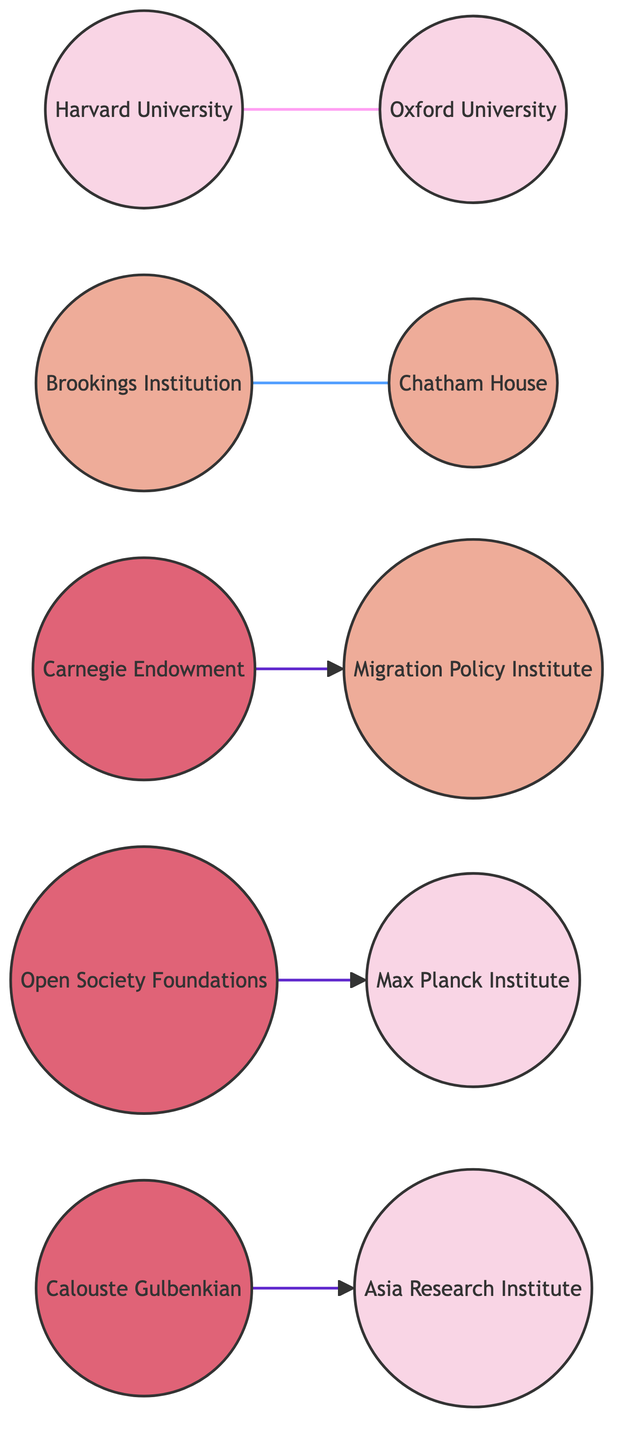What are the total number of nodes in the diagram? The diagram contains 10 nodes, which include various academic institutions, think tanks, and foundations listed in the data.
Answer: 10 What type of institution is Chatham House? Chatham House is identified as a "Think Tank" in the data provided, indicating its role in research and policy analysis.
Answer: Think Tank Which two nodes have a "Collaborative Research" relationship? The relationship of "Collaborative Research" exists between Harvard University and Oxford University, as reflected in the links data.
Answer: Harvard University and Oxford University What is the location of the Max Planck Institute for the Study of Religious and Ethnic Diversity? The data specifies that the Max Planck Institute for the Study of Religious and Ethnic Diversity is located in Göttingen, Germany.
Answer: Göttingen, Germany How many links are there between the nodes? The data lists 5 connections (links) between the institutions, showing various types of relationships among them.
Answer: 5 Which foundation is linked to the Migration Policy Institute? The Carnegie Endowment for International Peace has a link to the Migration Policy Institute, characterized as a "Funding" relationship.
Answer: Carnegie Endowment for International Peace What type of relationship connects Calouste Gulbenkian Foundation with Asia Research Institute? The type of relationship between Calouste Gulbenkian Foundation and Asia Research Institute is "Research Sponsorship," indicating financial or resource support for research activities.
Answer: Research Sponsorship What is the common type of relationship observed between the think tanks in the diagram? The relationships observed among the think tanks typically involve "Policy Analysis," demonstrating their focus on research-oriented policy work.
Answer: Policy Analysis Which academic institution collaborates with the Max Planck Institute through a grant support? The Open Society Foundations provide grant support to the Max Planck Institute for the Study of Religious and Ethnic Diversity, indicating financial backing for its research initiatives.
Answer: Open Society Foundations 